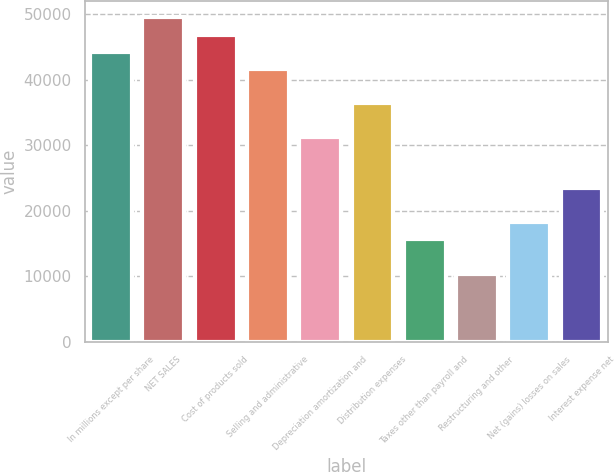Convert chart. <chart><loc_0><loc_0><loc_500><loc_500><bar_chart><fcel>In millions except per share<fcel>NET SALES<fcel>Cost of products sold<fcel>Selling and administrative<fcel>Depreciation amortization and<fcel>Distribution expenses<fcel>Taxes other than payroll and<fcel>Restructuring and other<fcel>Net (gains) losses on sales<fcel>Interest expense net<nl><fcel>44255.8<fcel>49462<fcel>46858.9<fcel>41652.6<fcel>31240.2<fcel>36446.4<fcel>15621.6<fcel>10415.4<fcel>18224.7<fcel>23430.9<nl></chart> 